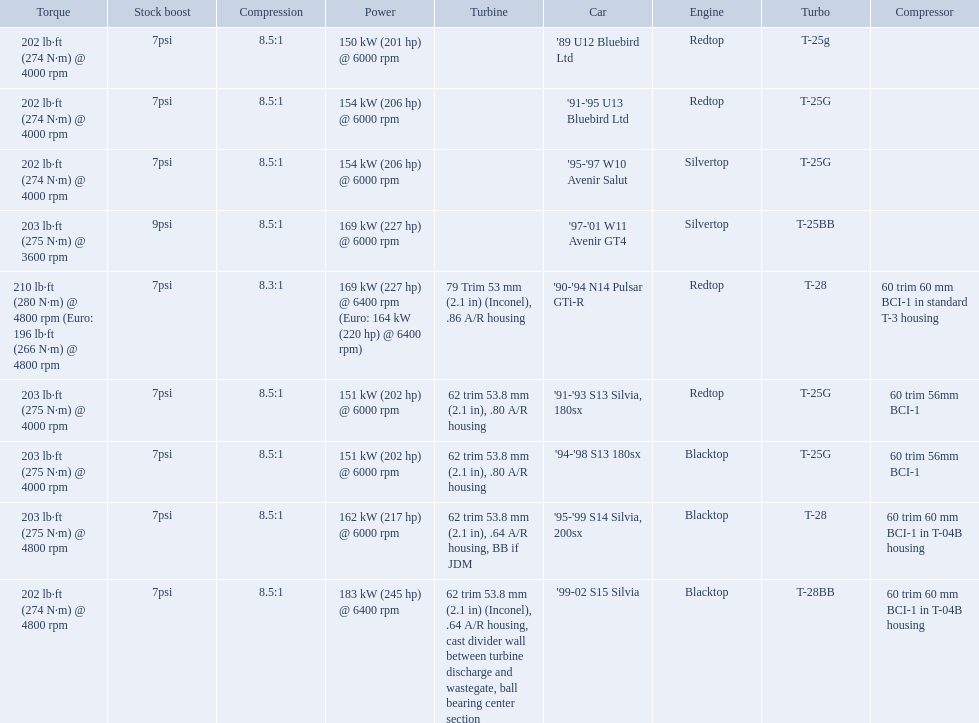What are all of the cars? '89 U12 Bluebird Ltd, '91-'95 U13 Bluebird Ltd, '95-'97 W10 Avenir Salut, '97-'01 W11 Avenir GT4, '90-'94 N14 Pulsar GTi-R, '91-'93 S13 Silvia, 180sx, '94-'98 S13 180sx, '95-'99 S14 Silvia, 200sx, '99-02 S15 Silvia. What is their rated power? 150 kW (201 hp) @ 6000 rpm, 154 kW (206 hp) @ 6000 rpm, 154 kW (206 hp) @ 6000 rpm, 169 kW (227 hp) @ 6000 rpm, 169 kW (227 hp) @ 6400 rpm (Euro: 164 kW (220 hp) @ 6400 rpm), 151 kW (202 hp) @ 6000 rpm, 151 kW (202 hp) @ 6000 rpm, 162 kW (217 hp) @ 6000 rpm, 183 kW (245 hp) @ 6400 rpm. Which car has the most power? '99-02 S15 Silvia. Could you help me parse every detail presented in this table? {'header': ['Torque', 'Stock boost', 'Compression', 'Power', 'Turbine', 'Car', 'Engine', 'Turbo', 'Compressor'], 'rows': [['202\xa0lb·ft (274\xa0N·m) @ 4000 rpm', '7psi', '8.5:1', '150\xa0kW (201\xa0hp) @ 6000 rpm', '', "'89 U12 Bluebird Ltd", 'Redtop', 'T-25g', ''], ['202\xa0lb·ft (274\xa0N·m) @ 4000 rpm', '7psi', '8.5:1', '154\xa0kW (206\xa0hp) @ 6000 rpm', '', "'91-'95 U13 Bluebird Ltd", 'Redtop', 'T-25G', ''], ['202\xa0lb·ft (274\xa0N·m) @ 4000 rpm', '7psi', '8.5:1', '154\xa0kW (206\xa0hp) @ 6000 rpm', '', "'95-'97 W10 Avenir Salut", 'Silvertop', 'T-25G', ''], ['203\xa0lb·ft (275\xa0N·m) @ 3600 rpm', '9psi', '8.5:1', '169\xa0kW (227\xa0hp) @ 6000 rpm', '', "'97-'01 W11 Avenir GT4", 'Silvertop', 'T-25BB', ''], ['210\xa0lb·ft (280\xa0N·m) @ 4800 rpm (Euro: 196\xa0lb·ft (266\xa0N·m) @ 4800 rpm', '7psi', '8.3:1', '169\xa0kW (227\xa0hp) @ 6400 rpm (Euro: 164\xa0kW (220\xa0hp) @ 6400 rpm)', '79 Trim 53\xa0mm (2.1\xa0in) (Inconel), .86 A/R housing', "'90-'94 N14 Pulsar GTi-R", 'Redtop', 'T-28', '60 trim 60\xa0mm BCI-1 in standard T-3 housing'], ['203\xa0lb·ft (275\xa0N·m) @ 4000 rpm', '7psi', '8.5:1', '151\xa0kW (202\xa0hp) @ 6000 rpm', '62 trim 53.8\xa0mm (2.1\xa0in), .80 A/R housing', "'91-'93 S13 Silvia, 180sx", 'Redtop', 'T-25G', '60 trim 56mm BCI-1'], ['203\xa0lb·ft (275\xa0N·m) @ 4000 rpm', '7psi', '8.5:1', '151\xa0kW (202\xa0hp) @ 6000 rpm', '62 trim 53.8\xa0mm (2.1\xa0in), .80 A/R housing', "'94-'98 S13 180sx", 'Blacktop', 'T-25G', '60 trim 56mm BCI-1'], ['203\xa0lb·ft (275\xa0N·m) @ 4800 rpm', '7psi', '8.5:1', '162\xa0kW (217\xa0hp) @ 6000 rpm', '62 trim 53.8\xa0mm (2.1\xa0in), .64 A/R housing, BB if JDM', "'95-'99 S14 Silvia, 200sx", 'Blacktop', 'T-28', '60 trim 60\xa0mm BCI-1 in T-04B housing'], ['202\xa0lb·ft (274\xa0N·m) @ 4800 rpm', '7psi', '8.5:1', '183\xa0kW (245\xa0hp) @ 6400 rpm', '62 trim 53.8\xa0mm (2.1\xa0in) (Inconel), .64 A/R housing, cast divider wall between turbine discharge and wastegate, ball bearing center section', "'99-02 S15 Silvia", 'Blacktop', 'T-28BB', '60 trim 60\xa0mm BCI-1 in T-04B housing']]} What are the psi's? 7psi, 7psi, 7psi, 9psi, 7psi, 7psi, 7psi, 7psi, 7psi. What are the number(s) greater than 7? 9psi. Which car has that number? '97-'01 W11 Avenir GT4. 